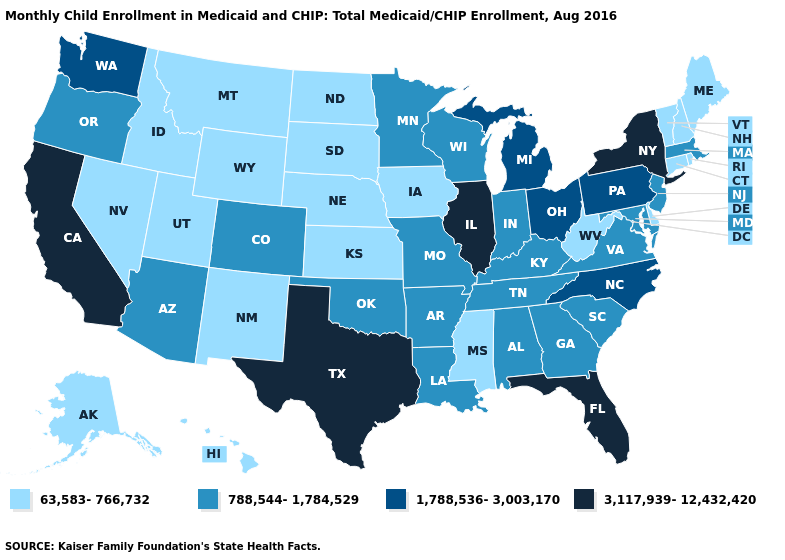Does New York have the highest value in the Northeast?
Quick response, please. Yes. Name the states that have a value in the range 788,544-1,784,529?
Keep it brief. Alabama, Arizona, Arkansas, Colorado, Georgia, Indiana, Kentucky, Louisiana, Maryland, Massachusetts, Minnesota, Missouri, New Jersey, Oklahoma, Oregon, South Carolina, Tennessee, Virginia, Wisconsin. Name the states that have a value in the range 3,117,939-12,432,420?
Answer briefly. California, Florida, Illinois, New York, Texas. Which states have the lowest value in the USA?
Answer briefly. Alaska, Connecticut, Delaware, Hawaii, Idaho, Iowa, Kansas, Maine, Mississippi, Montana, Nebraska, Nevada, New Hampshire, New Mexico, North Dakota, Rhode Island, South Dakota, Utah, Vermont, West Virginia, Wyoming. Name the states that have a value in the range 1,788,536-3,003,170?
Quick response, please. Michigan, North Carolina, Ohio, Pennsylvania, Washington. Name the states that have a value in the range 3,117,939-12,432,420?
Give a very brief answer. California, Florida, Illinois, New York, Texas. Does Michigan have the highest value in the MidWest?
Give a very brief answer. No. What is the value of Wyoming?
Give a very brief answer. 63,583-766,732. Among the states that border Connecticut , which have the lowest value?
Be succinct. Rhode Island. Does Maine have a higher value than Rhode Island?
Keep it brief. No. What is the value of Louisiana?
Concise answer only. 788,544-1,784,529. Does California have the highest value in the USA?
Quick response, please. Yes. Which states hav the highest value in the MidWest?
Write a very short answer. Illinois. Among the states that border Texas , does New Mexico have the highest value?
Give a very brief answer. No. What is the value of North Carolina?
Keep it brief. 1,788,536-3,003,170. 